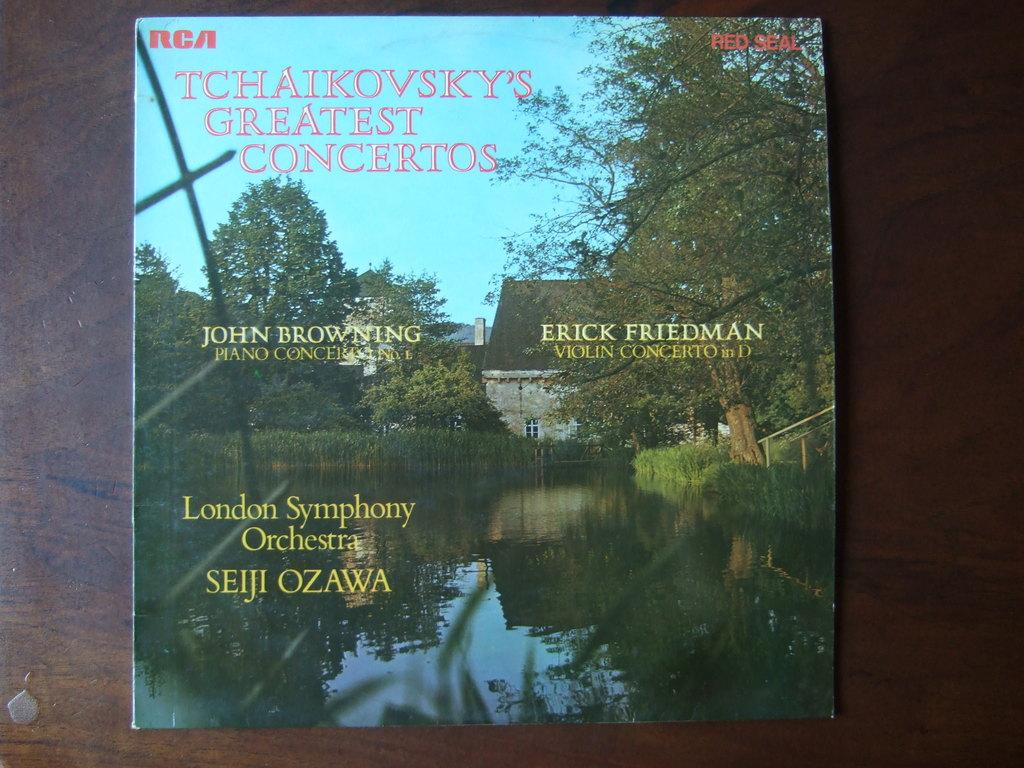Provide a one-sentence caption for the provided image. On a table is a copy of RCA RED SEAL Tchaikovsky's Greatest Concertos. 